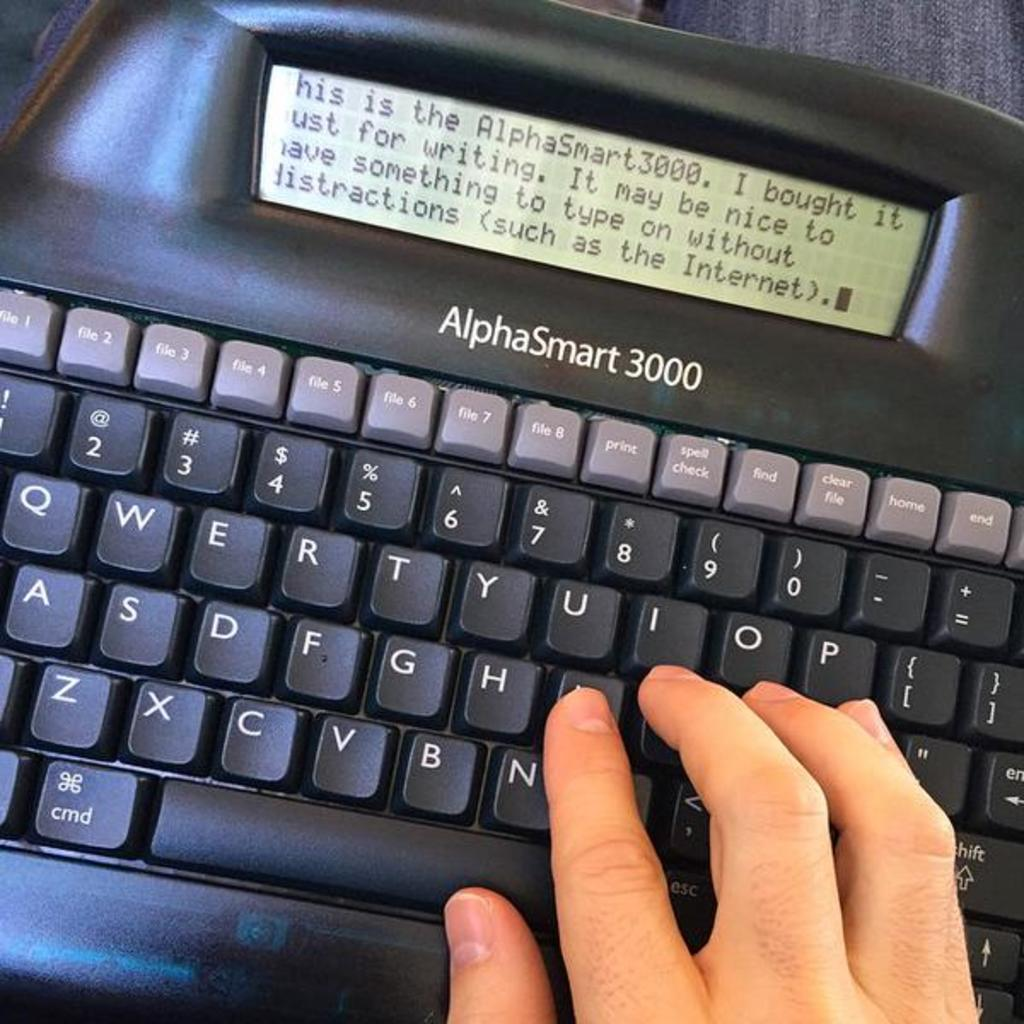Provide a one-sentence caption for the provided image. An AlphaSmart keyboard has a person typing on it. 